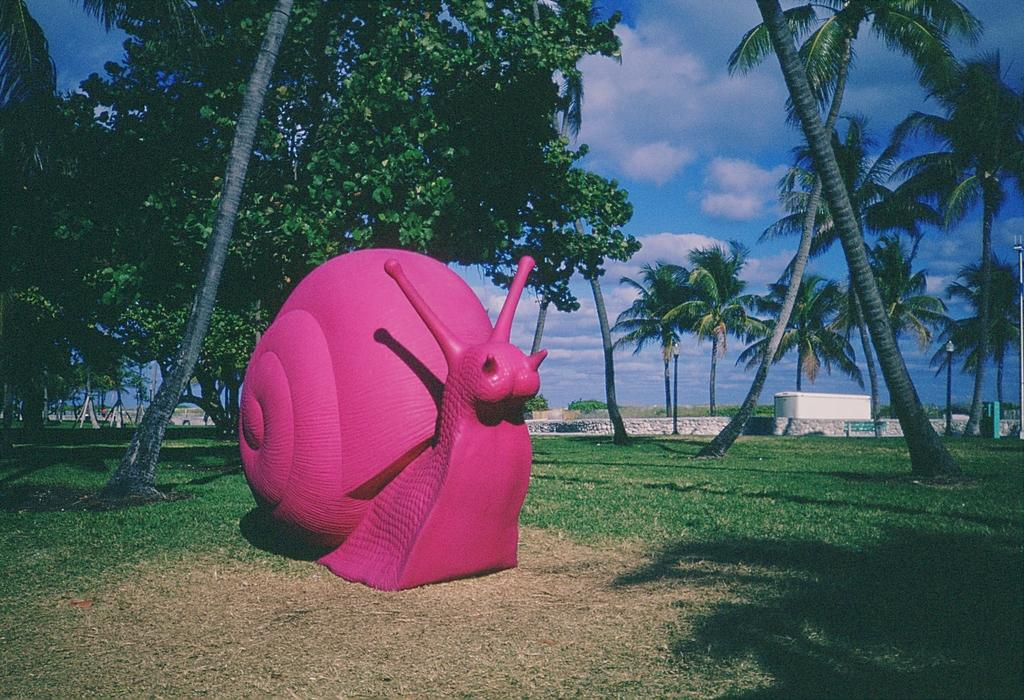What is the shape of the inflatable object on the grass in the image? The inflatable object on the grass is snail-shaped. What type of surface is the snail-shaped inflatable object resting on? The snail-shaped inflatable object is resting on the grass. What can be seen in the background of the image? There are trees in the background of the image. What type of advertisement can be seen on the snail-shaped inflatable object in the image? There is no advertisement visible on the snail-shaped inflatable object in the image. What kind of art is displayed on the grass in the image? There is no art displayed on the grass in the image; it only features the snail-shaped inflatable object. 